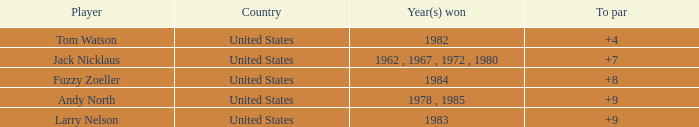What is the To par of the Player wtih Year(s) won of 1983? 9.0. 